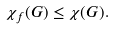<formula> <loc_0><loc_0><loc_500><loc_500>\chi _ { f } ( G ) \leq \chi ( G ) .</formula> 